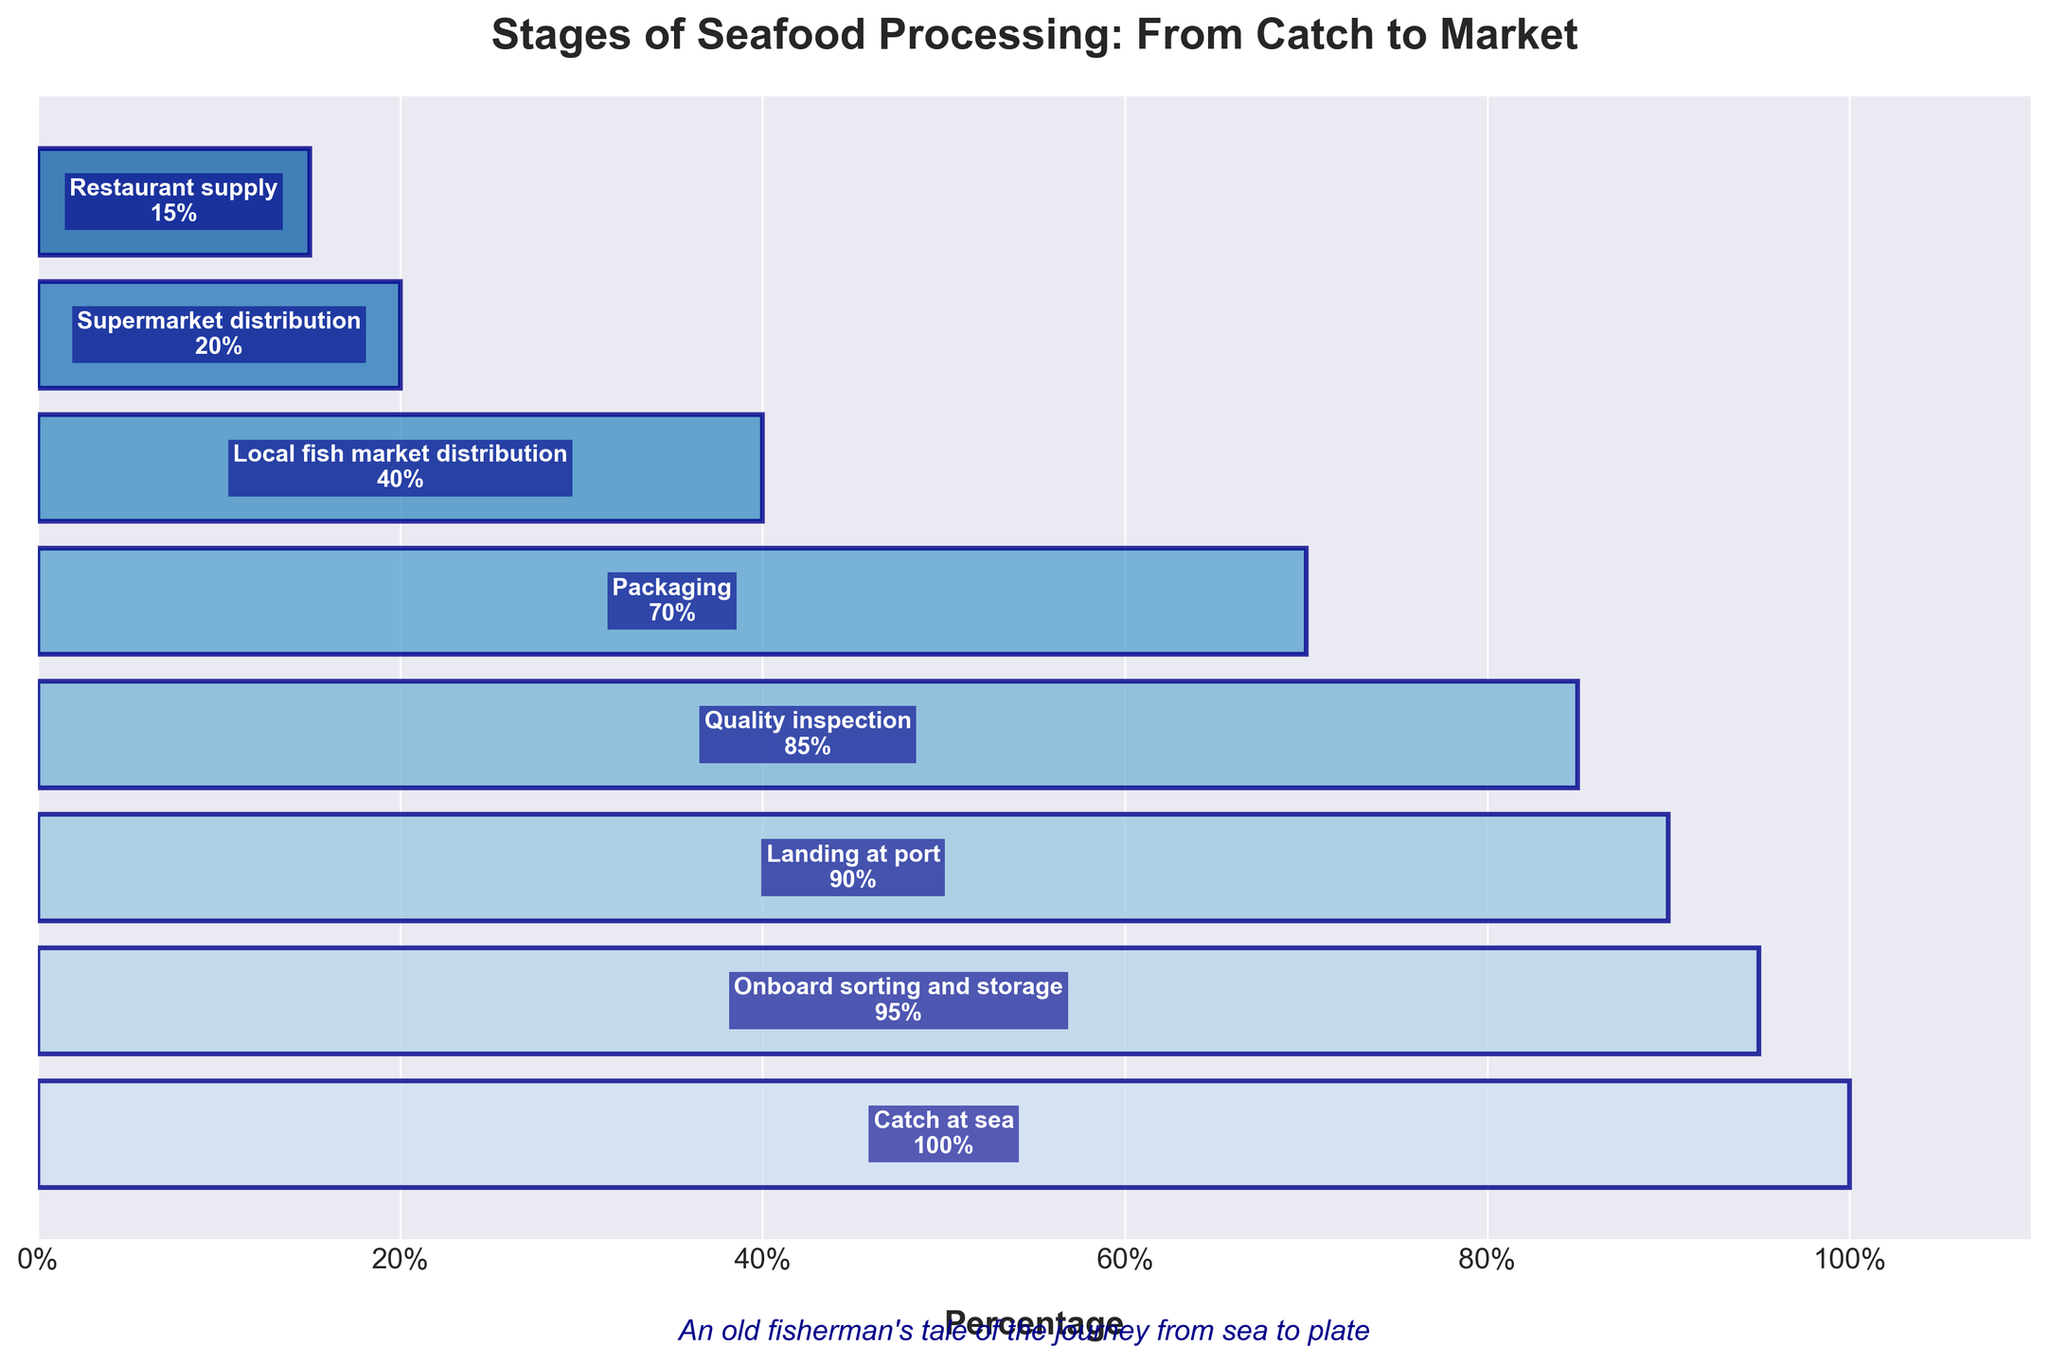what is the title of the figure? The title is usually placed at the top of a plot. In this case, it says "Stages of Seafood Processing: From Catch to Market".
Answer: Stages of Seafood Processing: From Catch to Market What stage has the highest percentage? By looking at the horizontal bars, the first stage, "Catch at sea", has the largest bar extending to 100%.
Answer: Catch at sea What is the percentage difference between "Packaging" and "Restaurant supply"? Locate the percentages for both "Packaging" (70%) and "Restaurant supply" (15%), and subtract the smaller value from the larger one: 70% - 15%.
Answer: 55% Which stage comes immediately after "Landing at port"? Find "Landing at port" in the list and see the next consecutive stage. The next stage is "Quality inspection".
Answer: Quality inspection What stages have a percentage below 50%? Identify stages where the bars extend less than halfway across the plot (below 50%): "Local fish market distribution" (40%), "Supermarket distribution" (20%), and "Restaurant supply" (15%).
Answer: Local fish market distribution, Supermarket distribution, Restaurant supply How many stages are there in total? Count the total number of stages listed in the plot. The stages are "Catch at sea", "Onboard sorting and storage", "Landing at port", "Quality inspection", "Packaging", "Local fish market distribution", "Supermarket distribution", and "Restaurant supply". There are eight stages in total.
Answer: 8 What percentage decrease is seen from "Onboard sorting and storage" to "Packaging"? Find the percentages for both stages: "Onboard sorting and storage" (95%) and "Packaging" (70%). Subtract the smaller value from the larger one: 95% - 70%.
Answer: 25% Which stage has the lowest percentage? By looking at the horizontal bars, the stage with the smallest bar extending to 15% is "Restaurant supply".
Answer: Restaurant supply What is the average percentage of all stages? Sum all the percentages: 100 + 95 + 90 + 85 + 70 + 40 + 20 + 15. There are 8 stages, so divide the sum by 8: (100 + 95 + 90 + 85 + 70 + 40 + 20 + 15) / 8.
Answer: 64.375 Which two consecutive stages have the largest percentage drop? Calculate the difference between each consecutive pair of stages and find the largest difference: "Catch at sea" to "Onboard sorting and storage" (100-95=5), "Onboard sorting and storage" to "Landing at port" (95-90=5), "Landing at port" to "Quality inspection" (90-85=5), "Quality inspection" to "Packaging" (85-70=15), "Packaging" to "Local fish market distribution" (70-40=30), "Local fish market distribution" to "Supermarket distribution" (40-20=20), "Supermarket distribution" to "Restaurant supply" (20-15=5). The largest drop is between "Packaging" and "Local fish market distribution" (70-40).
Answer: Packaging to Local fish market distribution 